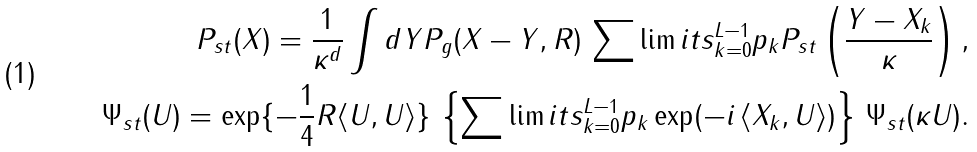<formula> <loc_0><loc_0><loc_500><loc_500>P _ { s t } ( X ) = \frac { 1 } { \kappa ^ { d } } \int d Y P _ { g } ( X - Y , R ) \, \sum \lim i t s _ { k = 0 } ^ { L - 1 } p _ { k } P _ { s t } \left ( \frac { Y - X _ { k } } { \kappa } \right ) , \\ \Psi _ { s t } ( U ) = \exp \{ - \frac { 1 } { 4 } R \langle U , U \rangle \} \, \left \{ \sum \lim i t s _ { k = 0 } ^ { L - 1 } p _ { k } \exp ( - i \, \langle X _ { k } , U \rangle ) \right \} \, \Psi _ { s t } ( \kappa U ) .</formula> 